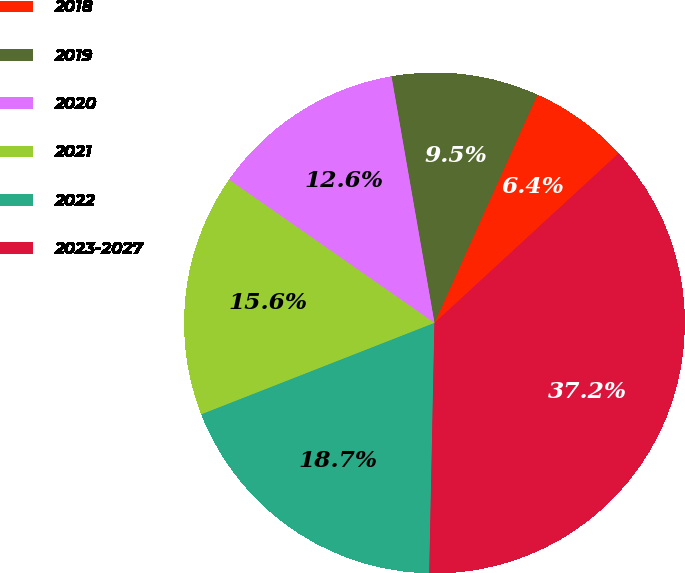Convert chart to OTSL. <chart><loc_0><loc_0><loc_500><loc_500><pie_chart><fcel>2018<fcel>2019<fcel>2020<fcel>2021<fcel>2022<fcel>2023-2027<nl><fcel>6.41%<fcel>9.49%<fcel>12.56%<fcel>15.64%<fcel>18.72%<fcel>37.18%<nl></chart> 